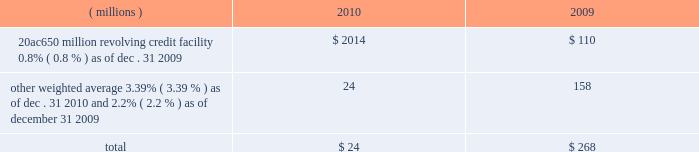Notes to the consolidated financial statements the credit agreement provides that loans will bear interest at rates based , at the company 2019s option , on one of two specified base rates plus a margin based on certain formulas defined in the credit agreement .
Additionally , the credit agreement contains a commitment fee on the amount of unused commitment under the credit agreement ranging from 0.125% ( 0.125 % ) to 0.625% ( 0.625 % ) per annum .
The applicable interest rate and the commitment fee will vary depending on the ratings established by standard & poor 2019s financial services llc and moody 2019s investor service inc .
For the company 2019s non-credit enhanced , long- term , senior , unsecured debt .
The credit agreement contains usual and customary restrictive covenants for facilities of its type , which include , with specified exceptions , limitations on the company 2019s ability to create liens or other encumbrances , to enter into sale and leaseback transactions and to enter into consolidations , mergers or transfers of all or substantially all of its assets .
The credit agreement also requires the company to maintain a ratio of total indebtedness to total capitalization , as defined in the credit agreement , of sixty percent or less .
The credit agreement contains customary events of default that would permit the lenders to accelerate the repayment of any loans , including the failure to make timely payments when due under the credit agreement or other material indebtedness , the failure to satisfy covenants contained in the credit agreement , a change in control of the company and specified events of bankruptcy and insolvency .
There were no amounts outstanding under the credit agreement at december 31 , on november 12 , 2010 , ppg completed a public offering of $ 250 million in aggregate principal amount of its 1.900% ( 1.900 % ) notes due 2016 ( the 201c2016 notes 201d ) , $ 500 million in aggregate principal amount of its 3.600% ( 3.600 % ) notes due 2020 ( the 201c2020 notes 201d ) and $ 250 million in aggregate principal amount of its 5.500% ( 5.500 % ) notes due 2040 ( the 201c2040 notes 201d ) .
These notes were issued pursuant to an indenture dated as of march 18 , 2008 ( the 201coriginal indenture 201d ) between the company and the bank of new york mellon trust company , n.a. , as trustee ( the 201ctrustee 201d ) , as supplemented by a first supplemental indenture dated as of march 18 , 2008 between the company and the trustee ( the 201cfirst supplemental indenture 201d ) and a second supplemental indenture dated as of november 12 , 2010 between the company and the trustee ( the 201csecond supplemental indenture 201d and , together with the original indenture and the first supplemental indenture , the 201cindenture 201d ) .
The company may issue additional debt from time to time pursuant to the original indenture .
The indenture governing these notes contains covenants that limit the company 2019s ability to , among other things , incur certain liens securing indebtedness , engage in certain sale-leaseback transactions , and enter into certain consolidations , mergers , conveyances , transfers or leases of all or substantially all the company 2019s assets .
The terms of these notes also require the company to make an offer to repurchase notes upon a change of control triggering event ( as defined in the second supplemental indenture ) at a price equal to 101% ( 101 % ) of their principal amount plus accrued and unpaid interest .
Cash proceeds from this notes offering was $ 983 million ( net of discount and issuance costs ) .
The discount and issuance costs related to these notes , which totaled $ 17 million , will be amortized to interest expense over the respective terms of the notes .
Ppg 2019s non-u.s .
Operations have uncommitted lines of credit totaling $ 791 million of which $ 31 million was used as of december 31 , 2010 .
These uncommitted lines of credit are subject to cancellation at any time and are generally not subject to any commitment fees .
Short-term debt outstanding as of december 31 , 2010 and 2009 , was as follows : ( millions ) 2010 2009 20ac650 million revolving credit facility , 0.8% ( 0.8 % ) as of dec .
31 , 2009 $ 2014 $ 110 other , weighted average 3.39% ( 3.39 % ) as of dec .
31 , 2010 and 2.2% ( 2.2 % ) as of december 31 , 2009 24 158 total $ 24 $ 268 ppg is in compliance with the restrictive covenants under its various credit agreements , loan agreements and indentures .
The company 2019s revolving credit agreements include a financial ratio covenant .
The covenant requires that the amount of total indebtedness not exceed 60% ( 60 % ) of the company 2019s total capitalization excluding the portion of accumulated other comprehensive income ( loss ) related to pensions and other postretirement benefit adjustments .
As of december 31 , 2010 , total indebtedness was 45% ( 45 % ) of the company 2019s total capitalization excluding the portion of accumulated other comprehensive income ( loss ) related to pensions and other postretirement benefit adjustments .
Additionally , substantially all of the company 2019s debt agreements contain customary cross- default provisions .
Those provisions generally provide that a default on a debt service payment of $ 10 million or more for longer than the grace period provided ( usually 10 days ) under one agreement may result in an event of default under other agreements .
None of the company 2019s primary debt obligations are secured or guaranteed by the company 2019s affiliates .
Interest payments in 2010 , 2009 and 2008 totaled $ 189 million , $ 201 million and $ 228 million , respectively .
2010 ppg annual report and form 10-k 43 .
Notes to the consolidated financial statements the credit agreement provides that loans will bear interest at rates based , at the company 2019s option , on one of two specified base rates plus a margin based on certain formulas defined in the credit agreement .
Additionally , the credit agreement contains a commitment fee on the amount of unused commitment under the credit agreement ranging from 0.125% ( 0.125 % ) to 0.625% ( 0.625 % ) per annum .
The applicable interest rate and the commitment fee will vary depending on the ratings established by standard & poor 2019s financial services llc and moody 2019s investor service inc .
For the company 2019s non-credit enhanced , long- term , senior , unsecured debt .
The credit agreement contains usual and customary restrictive covenants for facilities of its type , which include , with specified exceptions , limitations on the company 2019s ability to create liens or other encumbrances , to enter into sale and leaseback transactions and to enter into consolidations , mergers or transfers of all or substantially all of its assets .
The credit agreement also requires the company to maintain a ratio of total indebtedness to total capitalization , as defined in the credit agreement , of sixty percent or less .
The credit agreement contains customary events of default that would permit the lenders to accelerate the repayment of any loans , including the failure to make timely payments when due under the credit agreement or other material indebtedness , the failure to satisfy covenants contained in the credit agreement , a change in control of the company and specified events of bankruptcy and insolvency .
There were no amounts outstanding under the credit agreement at december 31 , on november 12 , 2010 , ppg completed a public offering of $ 250 million in aggregate principal amount of its 1.900% ( 1.900 % ) notes due 2016 ( the 201c2016 notes 201d ) , $ 500 million in aggregate principal amount of its 3.600% ( 3.600 % ) notes due 2020 ( the 201c2020 notes 201d ) and $ 250 million in aggregate principal amount of its 5.500% ( 5.500 % ) notes due 2040 ( the 201c2040 notes 201d ) .
These notes were issued pursuant to an indenture dated as of march 18 , 2008 ( the 201coriginal indenture 201d ) between the company and the bank of new york mellon trust company , n.a. , as trustee ( the 201ctrustee 201d ) , as supplemented by a first supplemental indenture dated as of march 18 , 2008 between the company and the trustee ( the 201cfirst supplemental indenture 201d ) and a second supplemental indenture dated as of november 12 , 2010 between the company and the trustee ( the 201csecond supplemental indenture 201d and , together with the original indenture and the first supplemental indenture , the 201cindenture 201d ) .
The company may issue additional debt from time to time pursuant to the original indenture .
The indenture governing these notes contains covenants that limit the company 2019s ability to , among other things , incur certain liens securing indebtedness , engage in certain sale-leaseback transactions , and enter into certain consolidations , mergers , conveyances , transfers or leases of all or substantially all the company 2019s assets .
The terms of these notes also require the company to make an offer to repurchase notes upon a change of control triggering event ( as defined in the second supplemental indenture ) at a price equal to 101% ( 101 % ) of their principal amount plus accrued and unpaid interest .
Cash proceeds from this notes offering was $ 983 million ( net of discount and issuance costs ) .
The discount and issuance costs related to these notes , which totaled $ 17 million , will be amortized to interest expense over the respective terms of the notes .
Ppg 2019s non-u.s .
Operations have uncommitted lines of credit totaling $ 791 million of which $ 31 million was used as of december 31 , 2010 .
These uncommitted lines of credit are subject to cancellation at any time and are generally not subject to any commitment fees .
Short-term debt outstanding as of december 31 , 2010 and 2009 , was as follows : ( millions ) 2010 2009 20ac650 million revolving credit facility , 0.8% ( 0.8 % ) as of dec .
31 , 2009 $ 2014 $ 110 other , weighted average 3.39% ( 3.39 % ) as of dec .
31 , 2010 and 2.2% ( 2.2 % ) as of december 31 , 2009 24 158 total $ 24 $ 268 ppg is in compliance with the restrictive covenants under its various credit agreements , loan agreements and indentures .
The company 2019s revolving credit agreements include a financial ratio covenant .
The covenant requires that the amount of total indebtedness not exceed 60% ( 60 % ) of the company 2019s total capitalization excluding the portion of accumulated other comprehensive income ( loss ) related to pensions and other postretirement benefit adjustments .
As of december 31 , 2010 , total indebtedness was 45% ( 45 % ) of the company 2019s total capitalization excluding the portion of accumulated other comprehensive income ( loss ) related to pensions and other postretirement benefit adjustments .
Additionally , substantially all of the company 2019s debt agreements contain customary cross- default provisions .
Those provisions generally provide that a default on a debt service payment of $ 10 million or more for longer than the grace period provided ( usually 10 days ) under one agreement may result in an event of default under other agreements .
None of the company 2019s primary debt obligations are secured or guaranteed by the company 2019s affiliates .
Interest payments in 2010 , 2009 and 2008 totaled $ 189 million , $ 201 million and $ 228 million , respectively .
2010 ppg annual report and form 10-k 43 .
What was the change in millions of interest payments from 2008 to 2009? 
Computations: (201 - 228)
Answer: -27.0. 